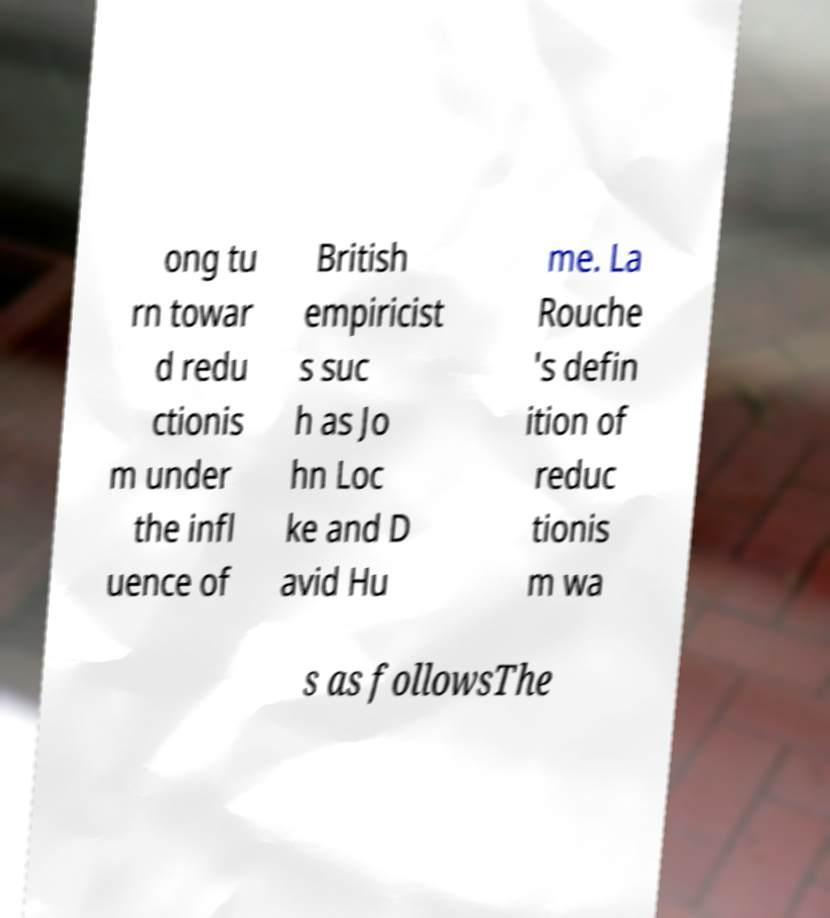There's text embedded in this image that I need extracted. Can you transcribe it verbatim? ong tu rn towar d redu ctionis m under the infl uence of British empiricist s suc h as Jo hn Loc ke and D avid Hu me. La Rouche 's defin ition of reduc tionis m wa s as followsThe 